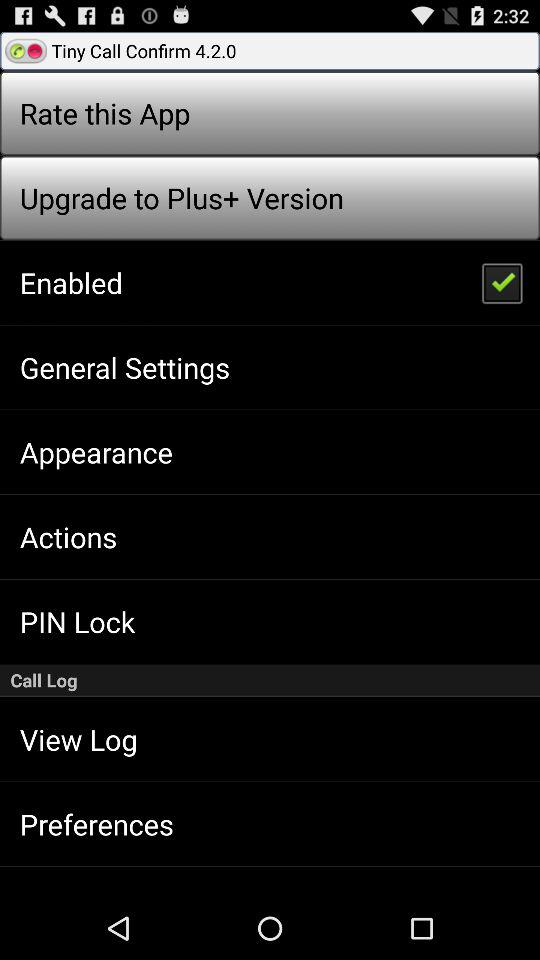Which version is it? It is version 4.2.0. 